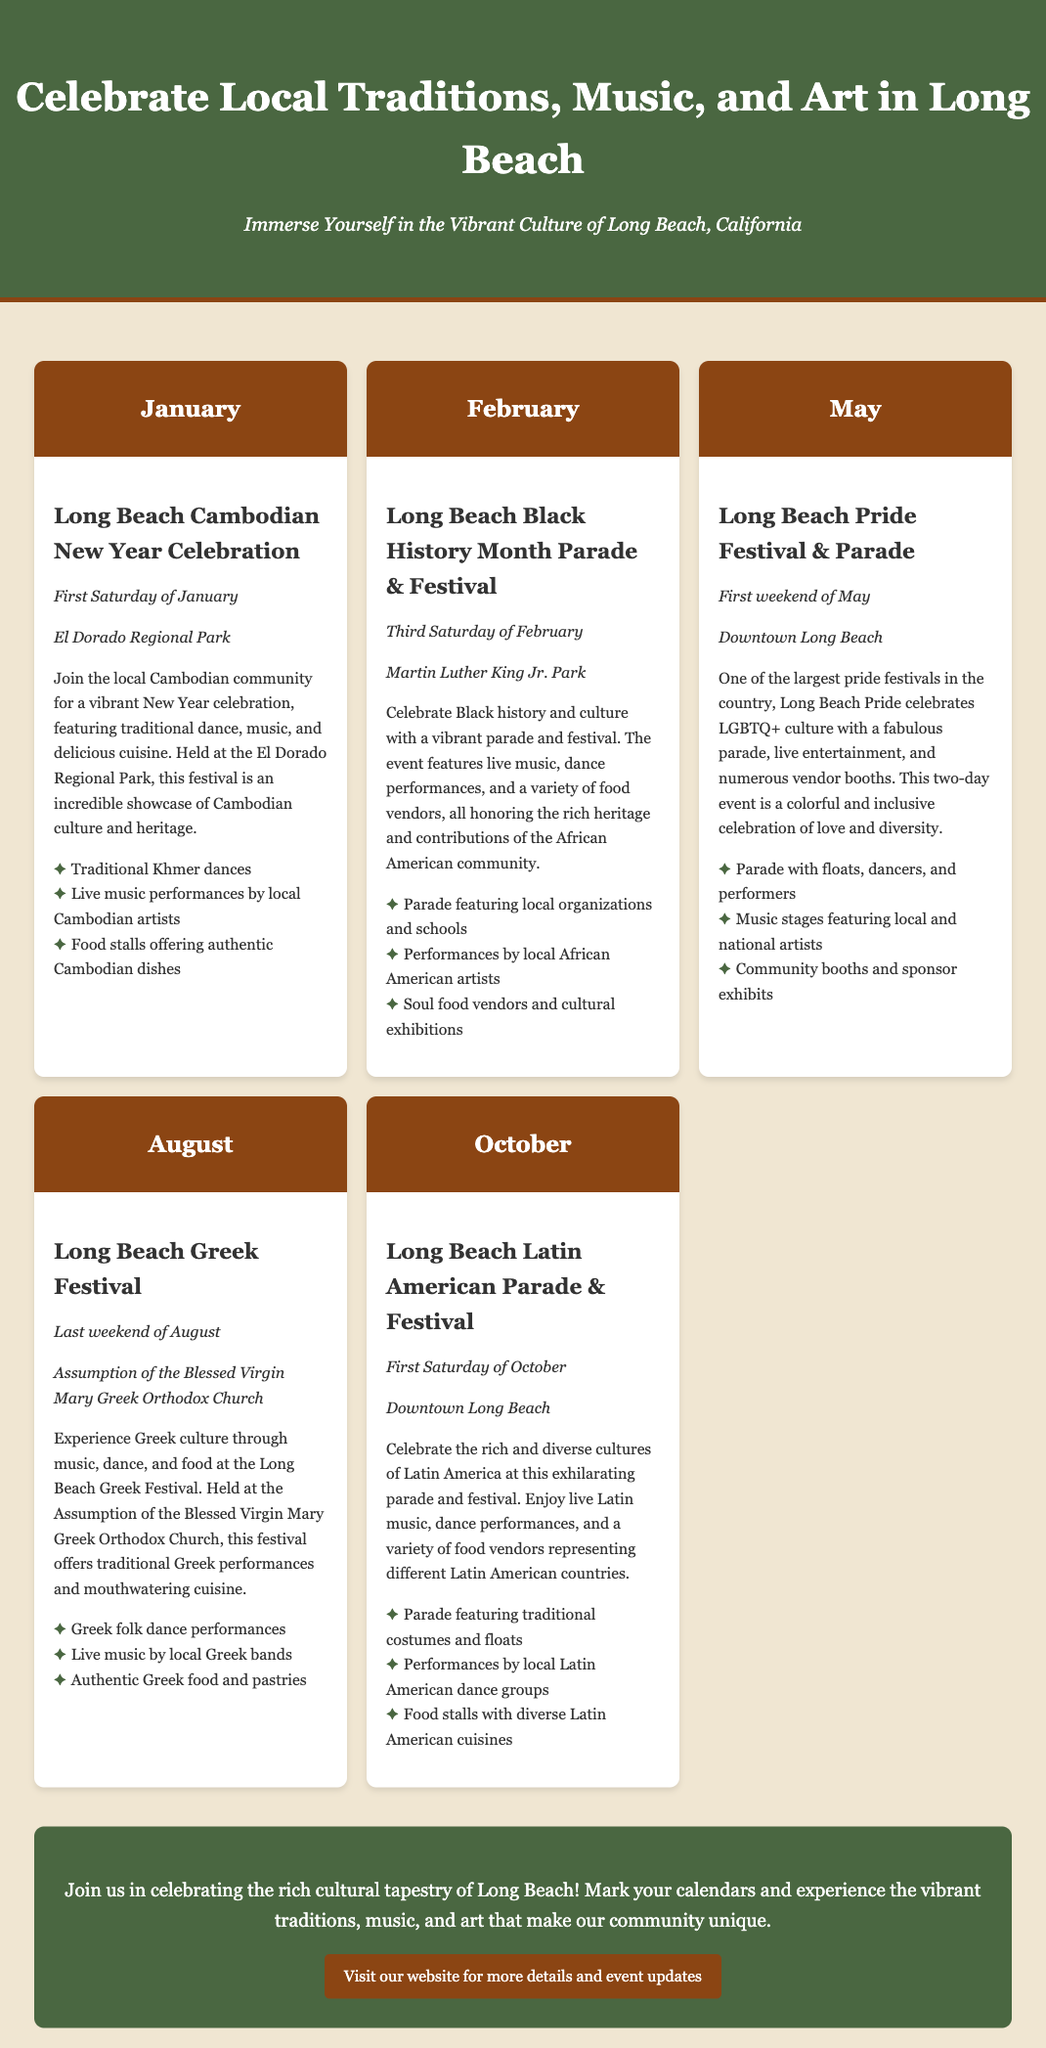What festival occurs on the first Saturday of January? The January festival is the Long Beach Cambodian New Year Celebration held on the first Saturday of January.
Answer: Long Beach Cambodian New Year Celebration When is the Long Beach Black History Month Parade & Festival? The Long Beach Black History Month Parade & Festival takes place on the third Saturday of February.
Answer: Third Saturday of February What is the location of the Long Beach Pride Festival & Parade? The Long Beach Pride Festival & Parade is held in Downtown Long Beach.
Answer: Downtown Long Beach What type of cuisine is featured at the Long Beach Greek Festival? The Long Beach Greek Festival offers authentic Greek food and pastries.
Answer: Authentic Greek food and pastries Which festival highlights Latin American culture? The festival celebrating Latin American culture is the Long Beach Latin American Parade & Festival.
Answer: Long Beach Latin American Parade & Festival How many festivals are mentioned in the document? The document mentions five cultural festivals happening throughout the year.
Answer: Five What is the last event of the year mentioned in the document? The last event mentioned is the Long Beach Latin American Parade & Festival in October.
Answer: Long Beach Latin American Parade & Festival What highlights the May festival? The highlights of the May festival include a parade with floats, dancers, and performers.
Answer: Parade with floats, dancers, and performers What do all cultural festivals in Long Beach celebrate? All cultural festivals in Long Beach celebrate local traditions, music, and art.
Answer: Local traditions, music, and art 